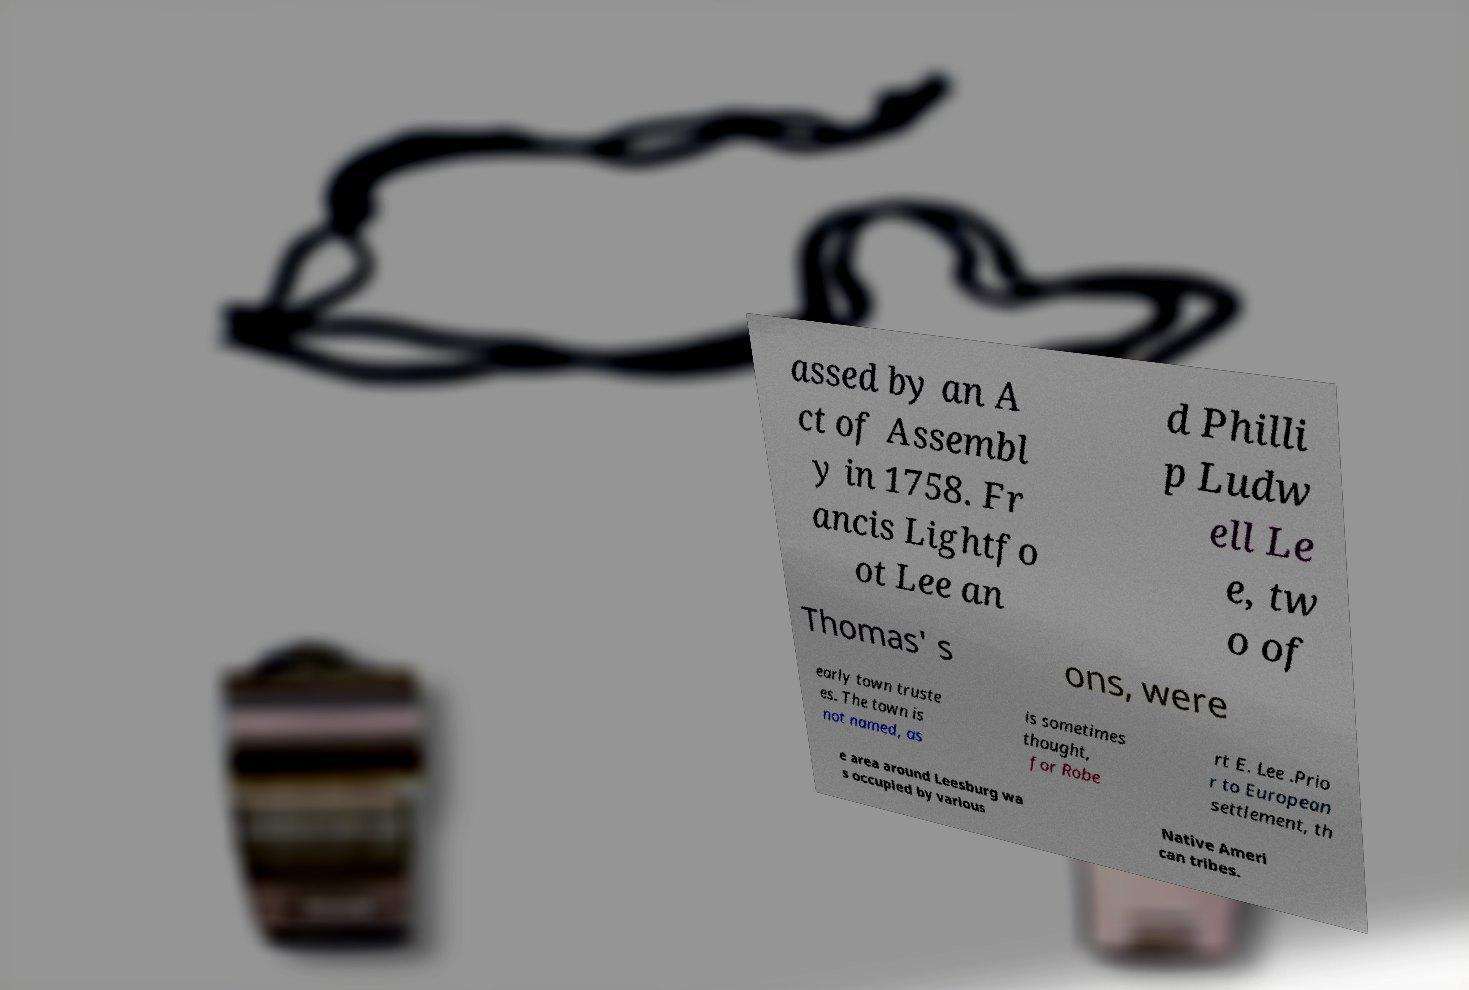There's text embedded in this image that I need extracted. Can you transcribe it verbatim? assed by an A ct of Assembl y in 1758. Fr ancis Lightfo ot Lee an d Philli p Ludw ell Le e, tw o of Thomas' s ons, were early town truste es. The town is not named, as is sometimes thought, for Robe rt E. Lee .Prio r to European settlement, th e area around Leesburg wa s occupied by various Native Ameri can tribes. 